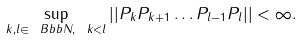Convert formula to latex. <formula><loc_0><loc_0><loc_500><loc_500>\sup _ { k , l \in { \ B b b N } , \ k < l } | | P _ { k } P _ { k + 1 } \dots P _ { l - 1 } P _ { l } | | < \infty .</formula> 